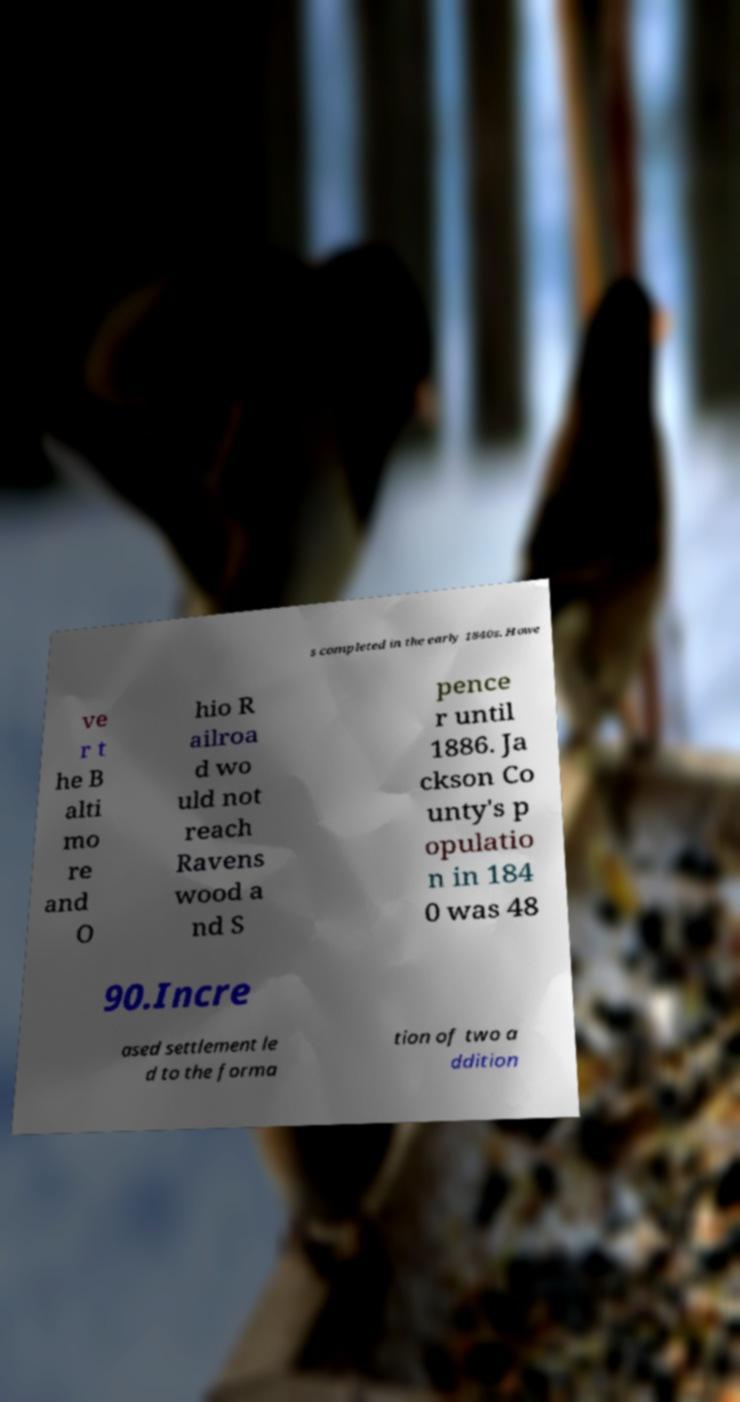Please read and relay the text visible in this image. What does it say? s completed in the early 1840s. Howe ve r t he B alti mo re and O hio R ailroa d wo uld not reach Ravens wood a nd S pence r until 1886. Ja ckson Co unty's p opulatio n in 184 0 was 48 90.Incre ased settlement le d to the forma tion of two a ddition 